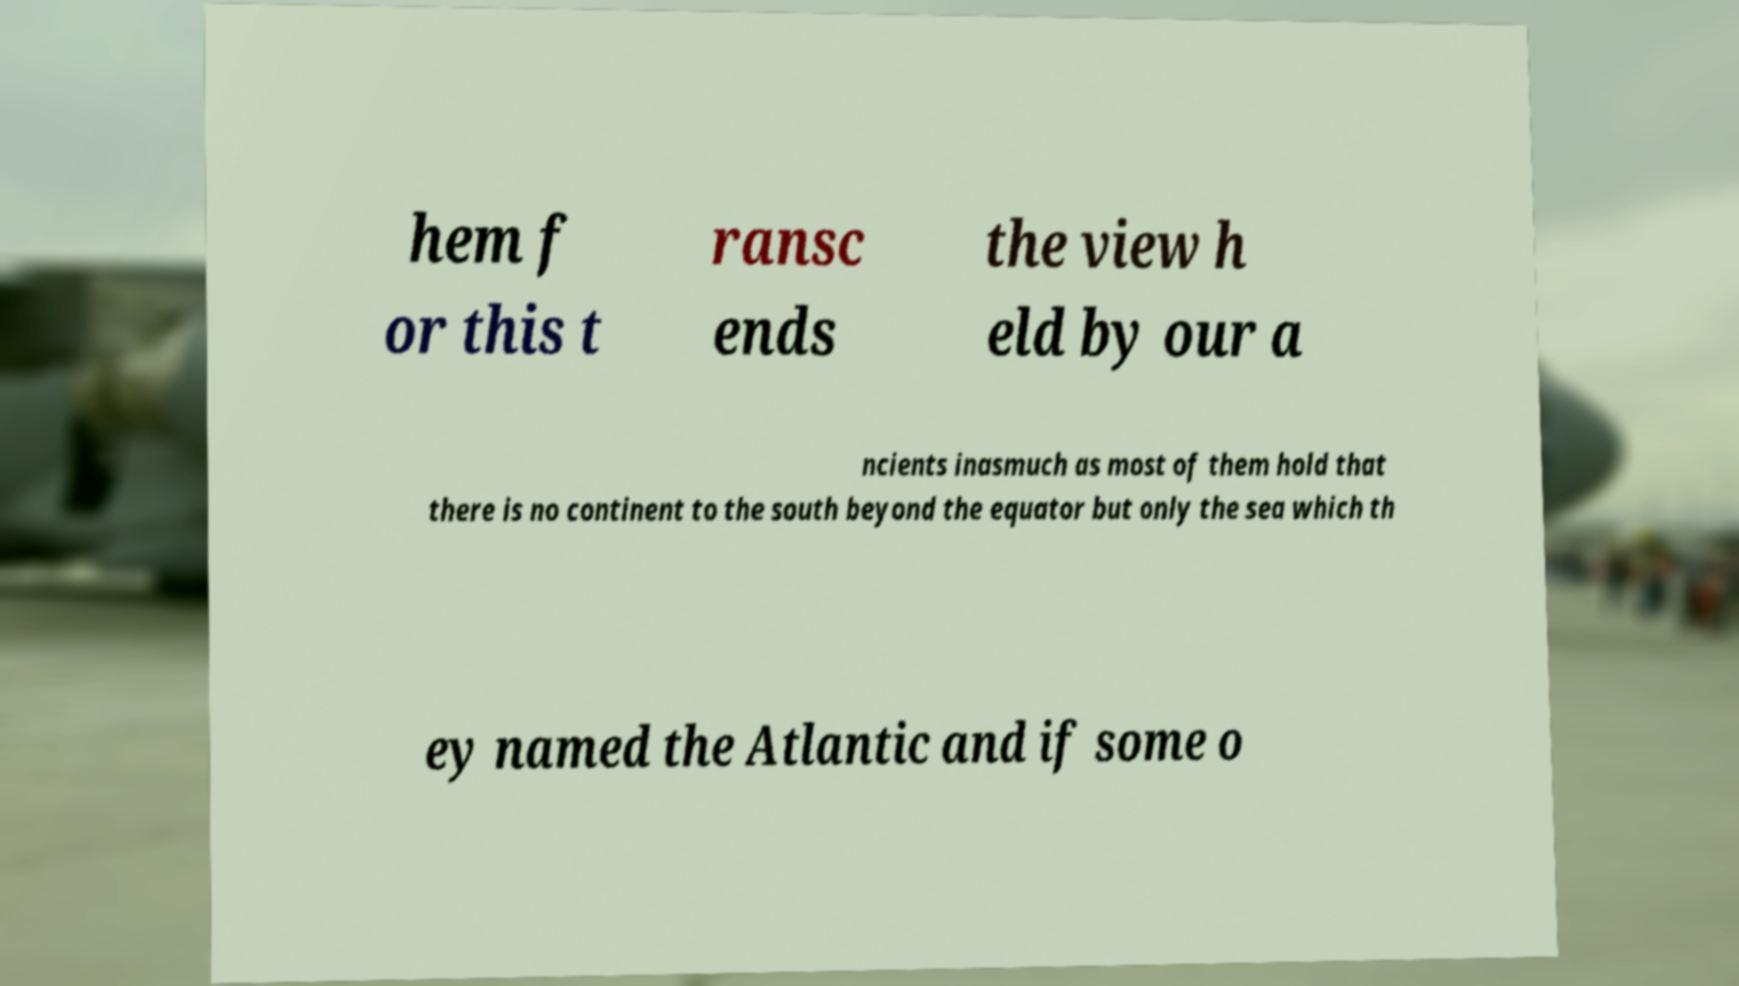There's text embedded in this image that I need extracted. Can you transcribe it verbatim? hem f or this t ransc ends the view h eld by our a ncients inasmuch as most of them hold that there is no continent to the south beyond the equator but only the sea which th ey named the Atlantic and if some o 